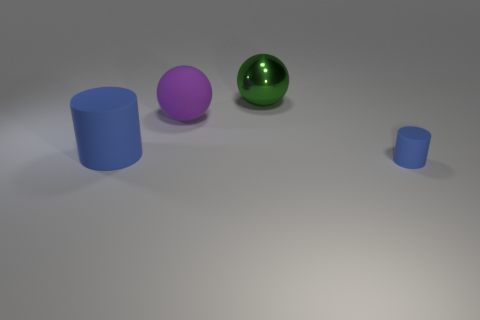Subtract all blue cylinders. How many were subtracted if there are1blue cylinders left? 1 Add 3 large cylinders. How many objects exist? 7 Add 4 big green metallic spheres. How many big green metallic spheres exist? 5 Subtract 1 green spheres. How many objects are left? 3 Subtract all big green metallic spheres. Subtract all large blue objects. How many objects are left? 2 Add 4 balls. How many balls are left? 6 